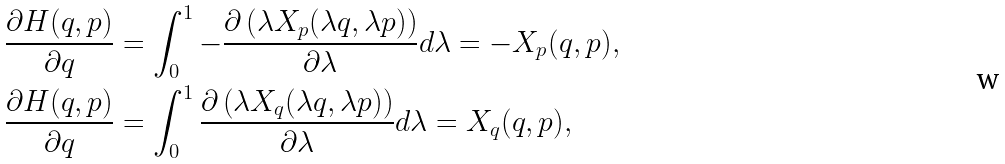<formula> <loc_0><loc_0><loc_500><loc_500>\frac { \partial H ( q , p ) } { \partial q } & = \int _ { 0 } ^ { 1 } - \frac { \partial \left ( \lambda X _ { p } ( \lambda q , \lambda p ) \right ) } { \partial \lambda } d \lambda = - X _ { p } ( q , p ) , \\ \frac { \partial H ( q , p ) } { \partial q } & = \int _ { 0 } ^ { 1 } \frac { \partial \left ( \lambda X _ { q } ( \lambda q , \lambda p ) \right ) } { \partial \lambda } d \lambda = X _ { q } ( q , p ) ,</formula> 